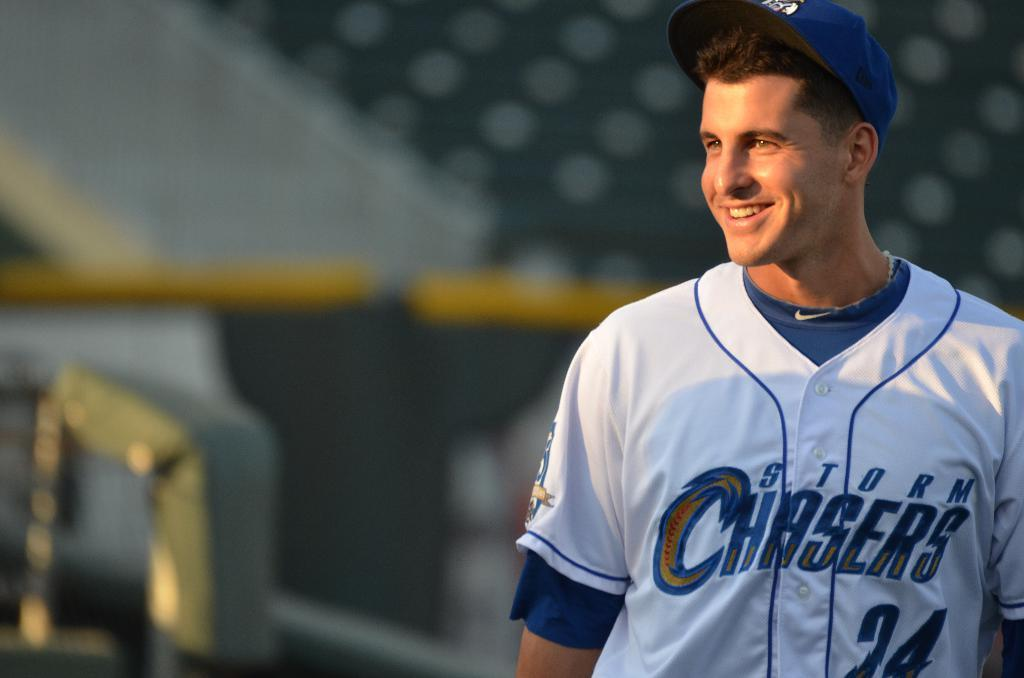<image>
Summarize the visual content of the image. Number 24 from the Storm Chasers stands smiling in the field 